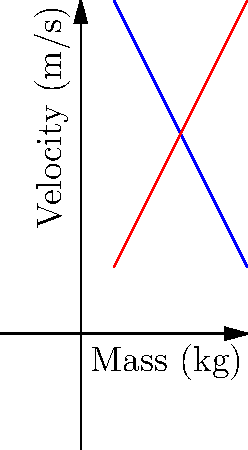In a patent dispute over sports equipment, two companies are debating the performance of their respective balls. Company A's baseball and Company B's cricket ball collide head-on. Given the graph showing the relationship between mass and velocity for both balls, calculate the change in momentum of the baseball if it has a mass of 2 kg and the cricket ball has a mass of 3 kg. Assume a perfectly elastic collision. To solve this problem, we'll follow these steps:

1) First, we need to determine the initial velocities of both balls from the graph:
   - Baseball (2 kg): $v_1 = 8$ m/s
   - Cricket ball (3 kg): $v_2 = 6$ m/s

2) In a perfectly elastic collision, momentum is conserved. We can use the equation:
   $m_1v_1 + m_2v_2 = m_1v_1' + m_2v_2'$
   where primed velocities are after collision.

3) Also, in a perfectly elastic collision, relative velocity is reversed:
   $v_1 - v_2 = -(v_1' - v_2')$

4) From (3), we can say: $v_1' - v_2' = -8 + 6 = -2$ m/s

5) Using conservation of momentum (2) and substituting known values:
   $2(8) + 3(6) = 2v_1' + 3v_2'$
   $16 + 18 = 2v_1' + 3v_2'$
   $34 = 2v_1' + 3v_2'$

6) We have two equations and two unknowns. From (4):
   $v_1' = v_2' - 2$

7) Substituting this into the equation from (5):
   $34 = 2(v_2' - 2) + 3v_2'$
   $34 = 2v_2' - 4 + 3v_2'$
   $38 = 5v_2'$
   $v_2' = 7.6$ m/s

8) Now we can find $v_1'$:
   $v_1' = 7.6 - 2 = 5.6$ m/s

9) The change in momentum of the baseball is:
   $\Delta p = m(v_1' - v_1) = 2(5.6 - 8) = -4.8$ kg⋅m/s

The negative sign indicates that the momentum decreased, which makes sense as the baseball was moving faster before the collision.
Answer: $-4.8$ kg⋅m/s 